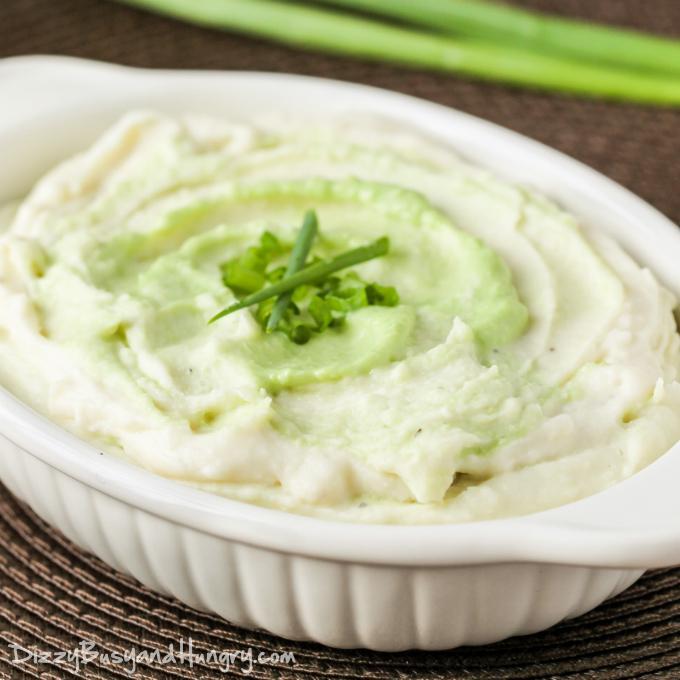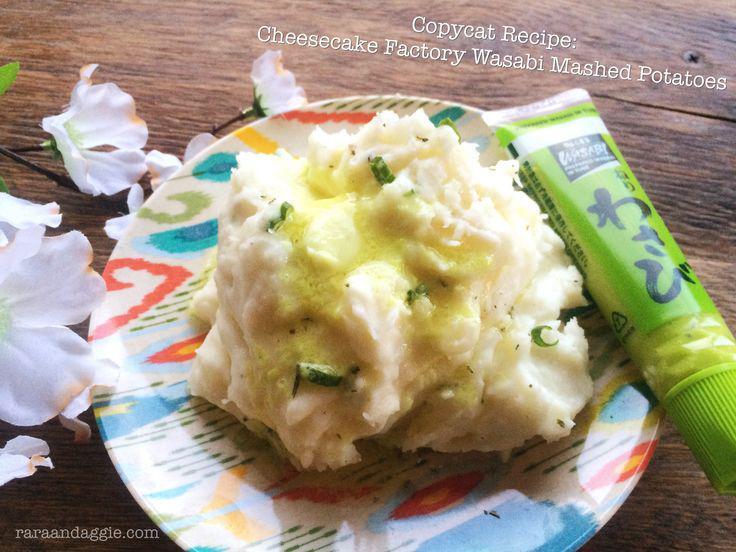The first image is the image on the left, the second image is the image on the right. For the images shown, is this caption "Left image shows food served in a white, non-square dish with textured design." true? Answer yes or no. Yes. 